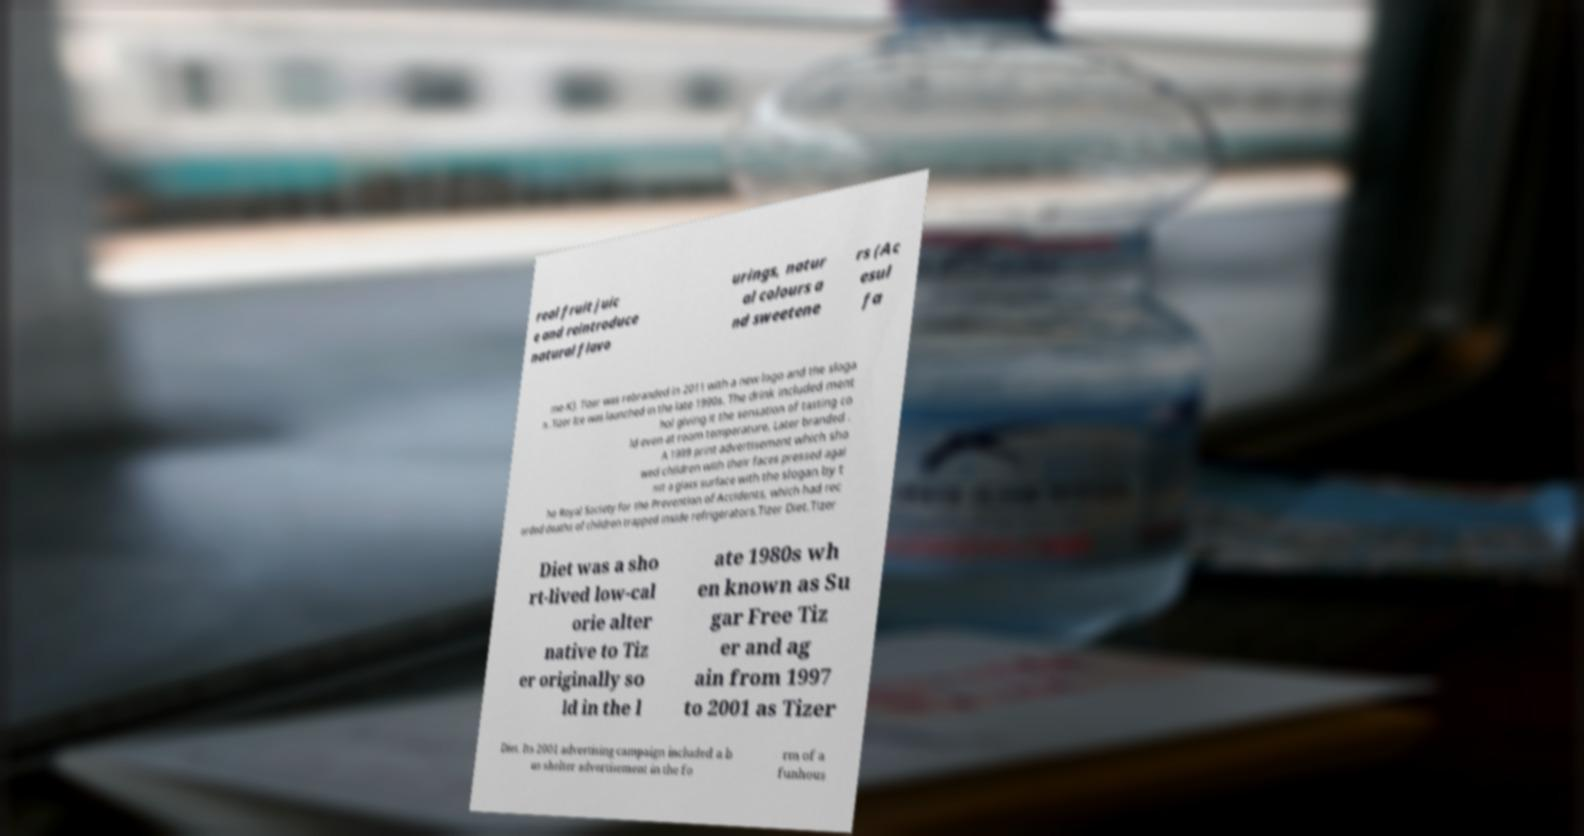Can you accurately transcribe the text from the provided image for me? real fruit juic e and reintroduce natural flavo urings, natur al colours a nd sweetene rs (Ac esul fa me-K). Tizer was rebranded in 2011 with a new logo and the sloga n .Tizer Ice was launched in the late 1990s. The drink included ment hol giving it the sensation of tasting co ld even at room temperature. Later branded . A 1999 print advertisement which sho wed children with their faces pressed agai nst a glass surface with the slogan by t he Royal Society for the Prevention of Accidents, which had rec orded deaths of children trapped inside refrigerators.Tizer Diet.Tizer Diet was a sho rt-lived low-cal orie alter native to Tiz er originally so ld in the l ate 1980s wh en known as Su gar Free Tiz er and ag ain from 1997 to 2001 as Tizer Diet. Its 2001 advertising campaign included a b us shelter advertisement in the fo rm of a funhous 